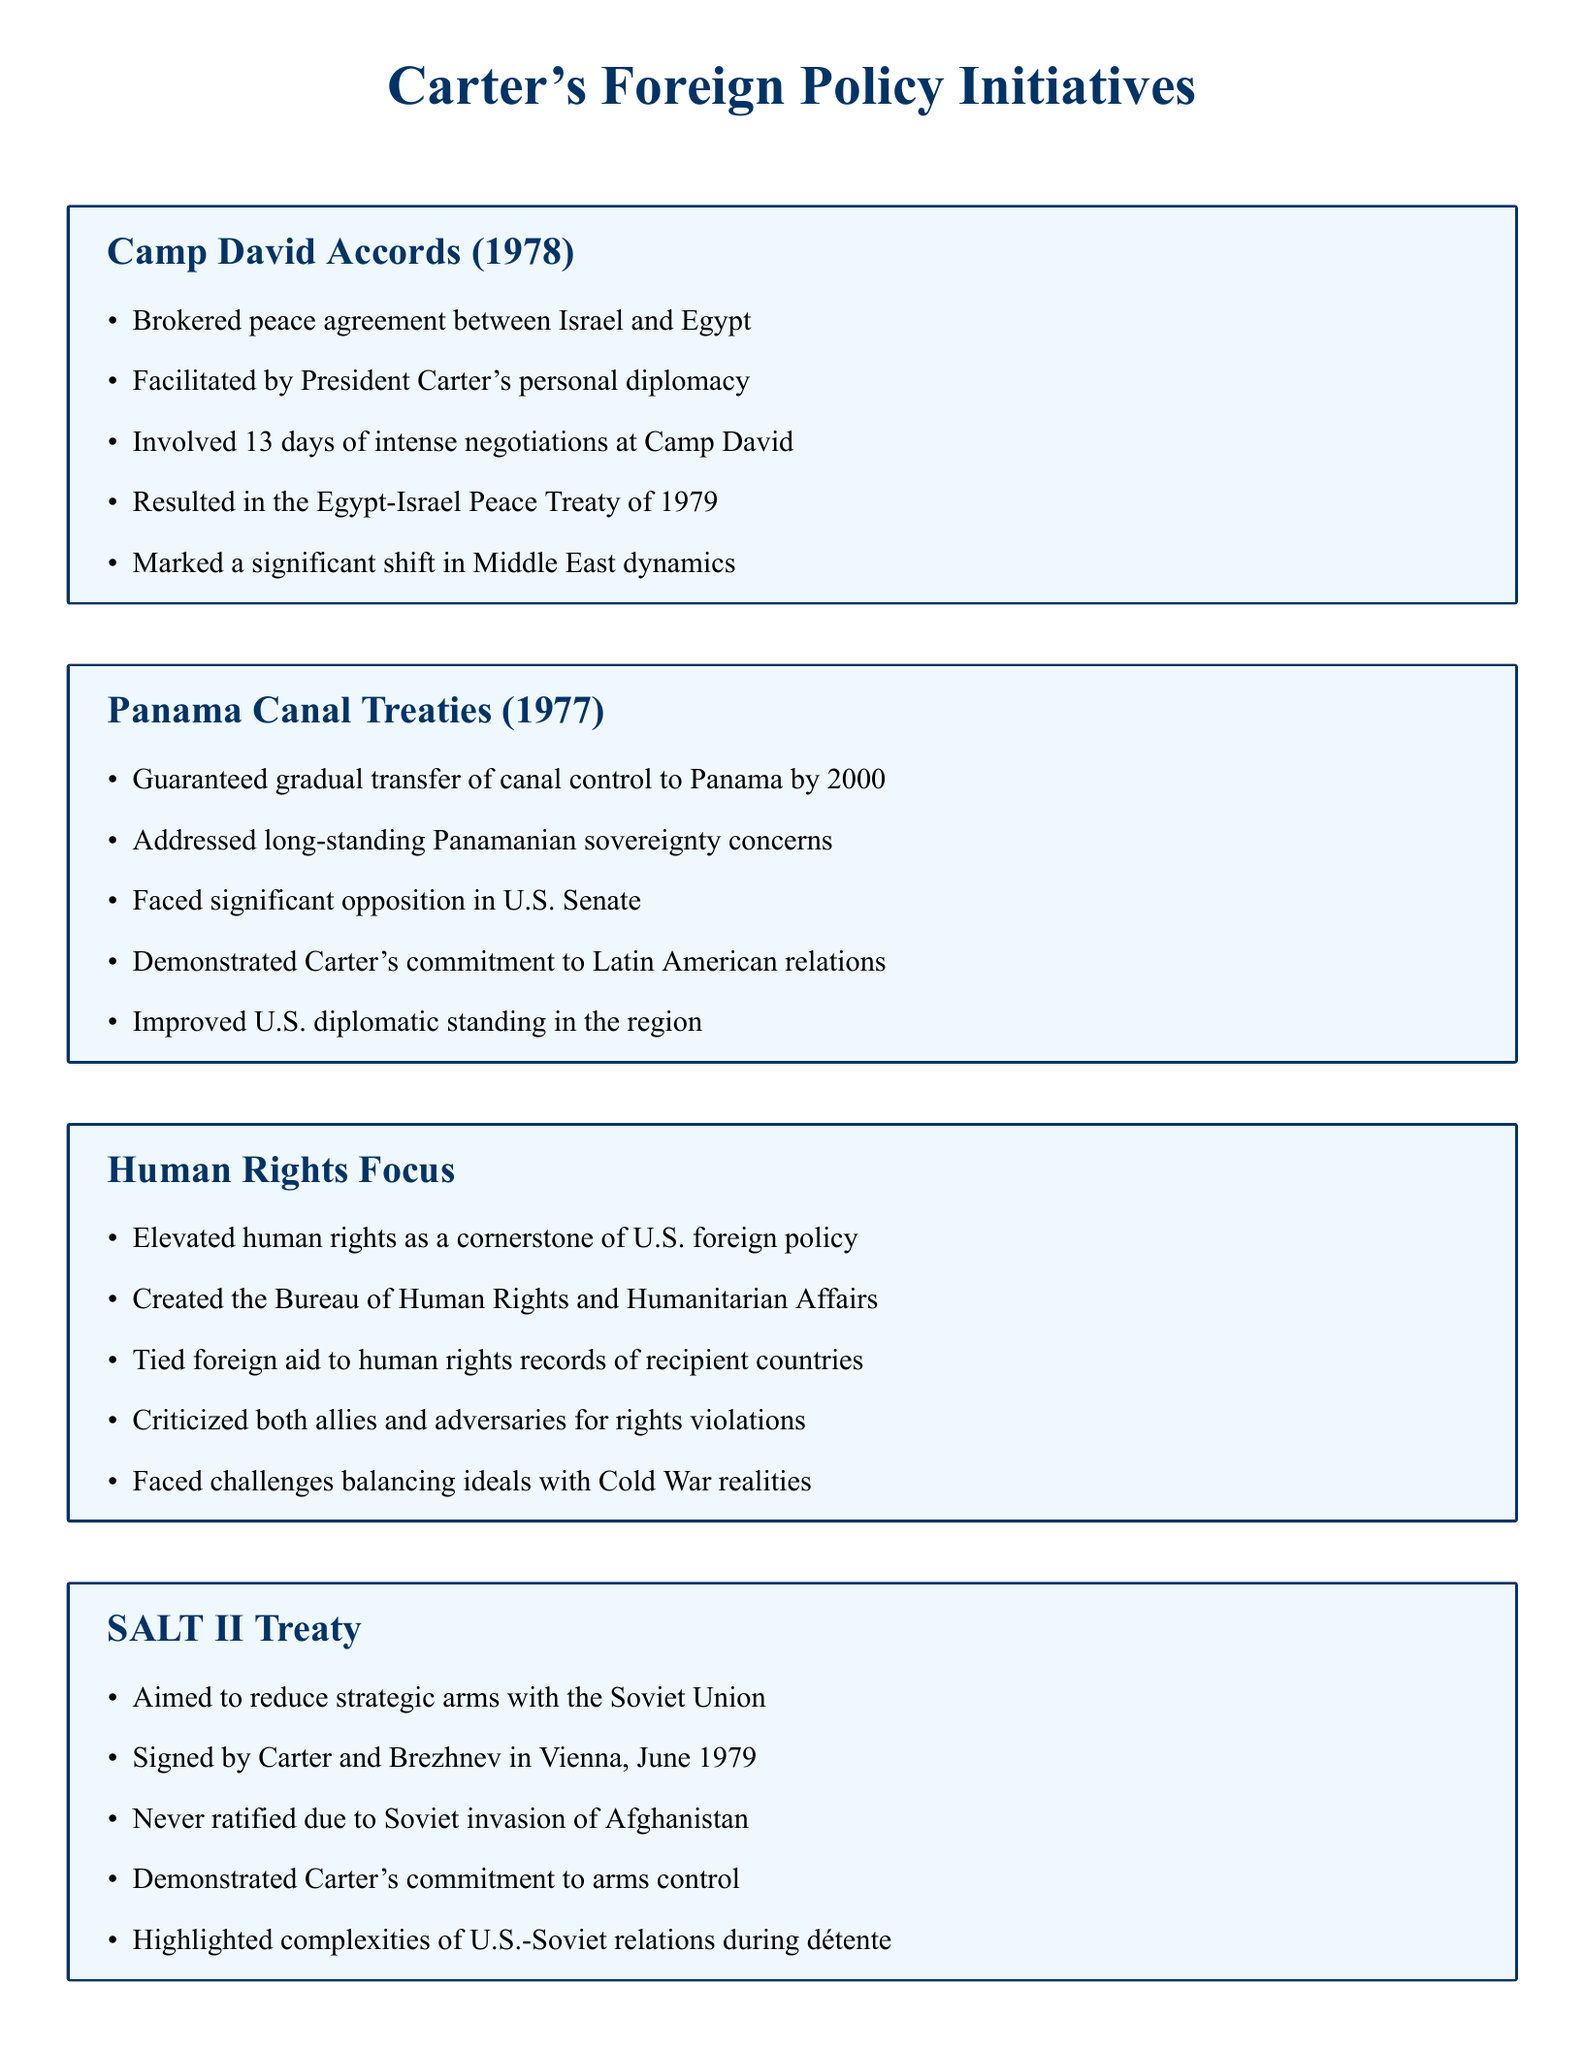What was the year of the Camp David Accords? The document states that the Camp David Accords took place in 1978.
Answer: 1978 Who facilitated the Camp David negotiations? The document mentions that President Carter's personal diplomacy facilitated the Camp David negotiations.
Answer: President Carter What was the goal of the SALT II Treaty? The document indicates that the SALT II Treaty aimed to reduce strategic arms with the Soviet Union.
Answer: Reduce strategic arms What country received control of the Panama Canal by 2000? According to the document, the gradual transfer of canal control was guaranteed to Panama.
Answer: Panama In which month and year was the SALT II Treaty signed? The document specifies that the SALT II Treaty was signed in June, 1979.
Answer: June, 1979 What were the Camp David Accords a significant shift in? The document states that the Camp David Accords marked a significant shift in Middle East dynamics.
Answer: Middle East dynamics What key focus elevated human rights in U.S. foreign policy? The document highlights that human rights were elevated as a cornerstone of U.S. foreign policy during Carter's presidency.
Answer: Human rights What was created to address human rights within U.S. foreign relations? According to the document, the Bureau of Human Rights and Humanitarian Affairs was created.
Answer: Bureau of Human Rights and Humanitarian Affairs What challenge did Carter face regarding human rights? The document mentions that Carter faced challenges balancing ideals with Cold War realities.
Answer: Balancing ideals with Cold War realities 